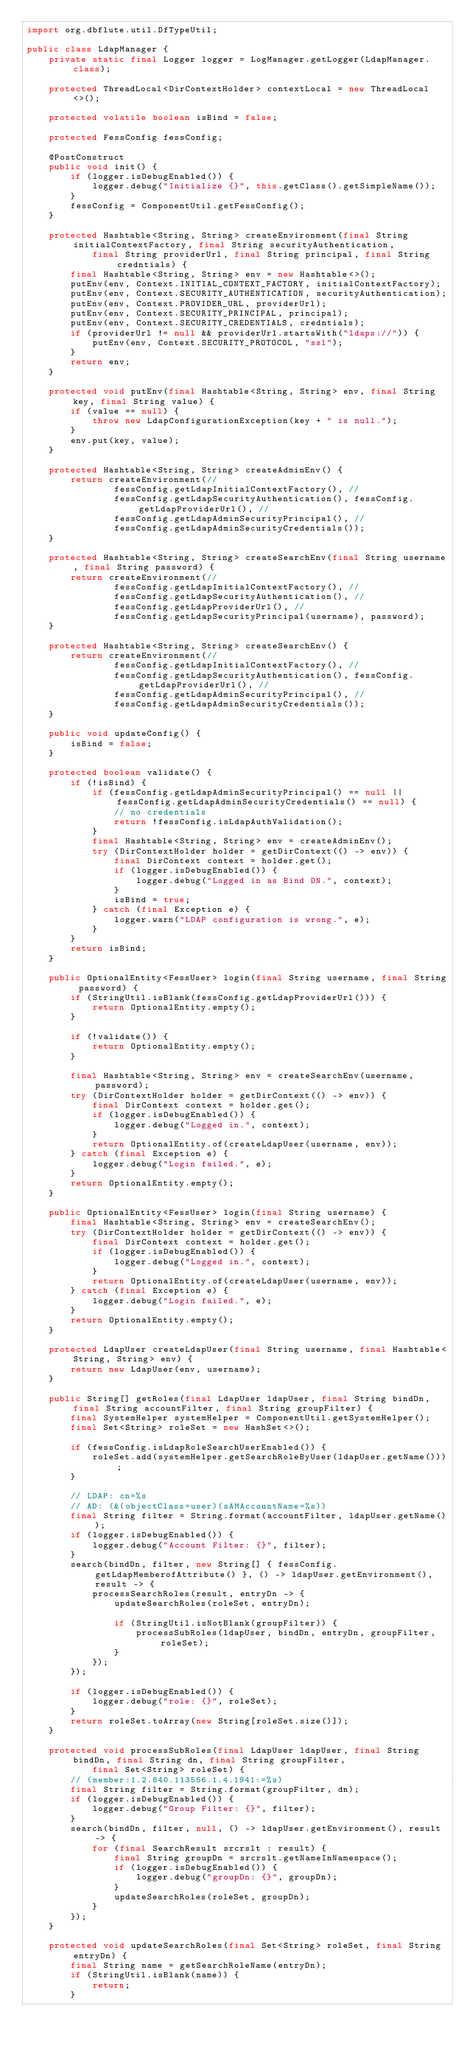<code> <loc_0><loc_0><loc_500><loc_500><_Java_>import org.dbflute.util.DfTypeUtil;

public class LdapManager {
    private static final Logger logger = LogManager.getLogger(LdapManager.class);

    protected ThreadLocal<DirContextHolder> contextLocal = new ThreadLocal<>();

    protected volatile boolean isBind = false;

    protected FessConfig fessConfig;

    @PostConstruct
    public void init() {
        if (logger.isDebugEnabled()) {
            logger.debug("Initialize {}", this.getClass().getSimpleName());
        }
        fessConfig = ComponentUtil.getFessConfig();
    }

    protected Hashtable<String, String> createEnvironment(final String initialContextFactory, final String securityAuthentication,
            final String providerUrl, final String principal, final String credntials) {
        final Hashtable<String, String> env = new Hashtable<>();
        putEnv(env, Context.INITIAL_CONTEXT_FACTORY, initialContextFactory);
        putEnv(env, Context.SECURITY_AUTHENTICATION, securityAuthentication);
        putEnv(env, Context.PROVIDER_URL, providerUrl);
        putEnv(env, Context.SECURITY_PRINCIPAL, principal);
        putEnv(env, Context.SECURITY_CREDENTIALS, credntials);
        if (providerUrl != null && providerUrl.startsWith("ldaps://")) {
            putEnv(env, Context.SECURITY_PROTOCOL, "ssl");
        }
        return env;
    }

    protected void putEnv(final Hashtable<String, String> env, final String key, final String value) {
        if (value == null) {
            throw new LdapConfigurationException(key + " is null.");
        }
        env.put(key, value);
    }

    protected Hashtable<String, String> createAdminEnv() {
        return createEnvironment(//
                fessConfig.getLdapInitialContextFactory(), //
                fessConfig.getLdapSecurityAuthentication(), fessConfig.getLdapProviderUrl(), //
                fessConfig.getLdapAdminSecurityPrincipal(), //
                fessConfig.getLdapAdminSecurityCredentials());
    }

    protected Hashtable<String, String> createSearchEnv(final String username, final String password) {
        return createEnvironment(//
                fessConfig.getLdapInitialContextFactory(), //
                fessConfig.getLdapSecurityAuthentication(), //
                fessConfig.getLdapProviderUrl(), //
                fessConfig.getLdapSecurityPrincipal(username), password);
    }

    protected Hashtable<String, String> createSearchEnv() {
        return createEnvironment(//
                fessConfig.getLdapInitialContextFactory(), //
                fessConfig.getLdapSecurityAuthentication(), fessConfig.getLdapProviderUrl(), //
                fessConfig.getLdapAdminSecurityPrincipal(), //
                fessConfig.getLdapAdminSecurityCredentials());
    }

    public void updateConfig() {
        isBind = false;
    }

    protected boolean validate() {
        if (!isBind) {
            if (fessConfig.getLdapAdminSecurityPrincipal() == null || fessConfig.getLdapAdminSecurityCredentials() == null) {
                // no credentials
                return !fessConfig.isLdapAuthValidation();
            }
            final Hashtable<String, String> env = createAdminEnv();
            try (DirContextHolder holder = getDirContext(() -> env)) {
                final DirContext context = holder.get();
                if (logger.isDebugEnabled()) {
                    logger.debug("Logged in as Bind DN.", context);
                }
                isBind = true;
            } catch (final Exception e) {
                logger.warn("LDAP configuration is wrong.", e);
            }
        }
        return isBind;
    }

    public OptionalEntity<FessUser> login(final String username, final String password) {
        if (StringUtil.isBlank(fessConfig.getLdapProviderUrl())) {
            return OptionalEntity.empty();
        }

        if (!validate()) {
            return OptionalEntity.empty();
        }

        final Hashtable<String, String> env = createSearchEnv(username, password);
        try (DirContextHolder holder = getDirContext(() -> env)) {
            final DirContext context = holder.get();
            if (logger.isDebugEnabled()) {
                logger.debug("Logged in.", context);
            }
            return OptionalEntity.of(createLdapUser(username, env));
        } catch (final Exception e) {
            logger.debug("Login failed.", e);
        }
        return OptionalEntity.empty();
    }

    public OptionalEntity<FessUser> login(final String username) {
        final Hashtable<String, String> env = createSearchEnv();
        try (DirContextHolder holder = getDirContext(() -> env)) {
            final DirContext context = holder.get();
            if (logger.isDebugEnabled()) {
                logger.debug("Logged in.", context);
            }
            return OptionalEntity.of(createLdapUser(username, env));
        } catch (final Exception e) {
            logger.debug("Login failed.", e);
        }
        return OptionalEntity.empty();
    }

    protected LdapUser createLdapUser(final String username, final Hashtable<String, String> env) {
        return new LdapUser(env, username);
    }

    public String[] getRoles(final LdapUser ldapUser, final String bindDn, final String accountFilter, final String groupFilter) {
        final SystemHelper systemHelper = ComponentUtil.getSystemHelper();
        final Set<String> roleSet = new HashSet<>();

        if (fessConfig.isLdapRoleSearchUserEnabled()) {
            roleSet.add(systemHelper.getSearchRoleByUser(ldapUser.getName()));
        }

        // LDAP: cn=%s
        // AD: (&(objectClass=user)(sAMAccountName=%s))
        final String filter = String.format(accountFilter, ldapUser.getName());
        if (logger.isDebugEnabled()) {
            logger.debug("Account Filter: {}", filter);
        }
        search(bindDn, filter, new String[] { fessConfig.getLdapMemberofAttribute() }, () -> ldapUser.getEnvironment(), result -> {
            processSearchRoles(result, entryDn -> {
                updateSearchRoles(roleSet, entryDn);

                if (StringUtil.isNotBlank(groupFilter)) {
                    processSubRoles(ldapUser, bindDn, entryDn, groupFilter, roleSet);
                }
            });
        });

        if (logger.isDebugEnabled()) {
            logger.debug("role: {}", roleSet);
        }
        return roleSet.toArray(new String[roleSet.size()]);
    }

    protected void processSubRoles(final LdapUser ldapUser, final String bindDn, final String dn, final String groupFilter,
            final Set<String> roleSet) {
        // (member:1.2.840.113556.1.4.1941:=%s)
        final String filter = String.format(groupFilter, dn);
        if (logger.isDebugEnabled()) {
            logger.debug("Group Filter: {}", filter);
        }
        search(bindDn, filter, null, () -> ldapUser.getEnvironment(), result -> {
            for (final SearchResult srcrslt : result) {
                final String groupDn = srcrslt.getNameInNamespace();
                if (logger.isDebugEnabled()) {
                    logger.debug("groupDn: {}", groupDn);
                }
                updateSearchRoles(roleSet, groupDn);
            }
        });
    }

    protected void updateSearchRoles(final Set<String> roleSet, final String entryDn) {
        final String name = getSearchRoleName(entryDn);
        if (StringUtil.isBlank(name)) {
            return;
        }
</code> 